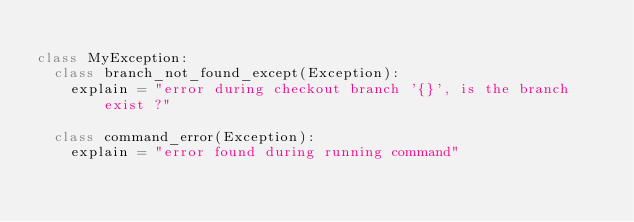<code> <loc_0><loc_0><loc_500><loc_500><_Python_>
class MyException:
  class branch_not_found_except(Exception):
    explain = "error during checkout branch '{}', is the branch exist ?"

  class command_error(Exception):
    explain = "error found during running command"
</code> 